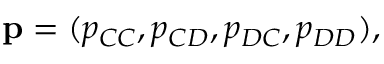Convert formula to latex. <formula><loc_0><loc_0><loc_500><loc_500>p = ( p _ { C C } , p _ { C D } , p _ { D C } , p _ { D D } ) ,</formula> 